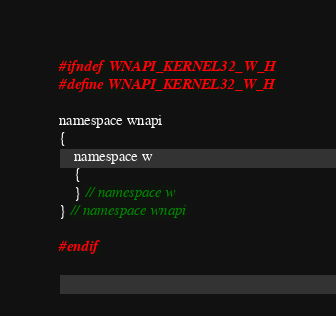Convert code to text. <code><loc_0><loc_0><loc_500><loc_500><_C_>#ifndef WNAPI_KERNEL32_W_H
#define WNAPI_KERNEL32_W_H

namespace wnapi
{
    namespace w
    {
    } // namespace w
} // namespace wnapi

#endif
</code> 